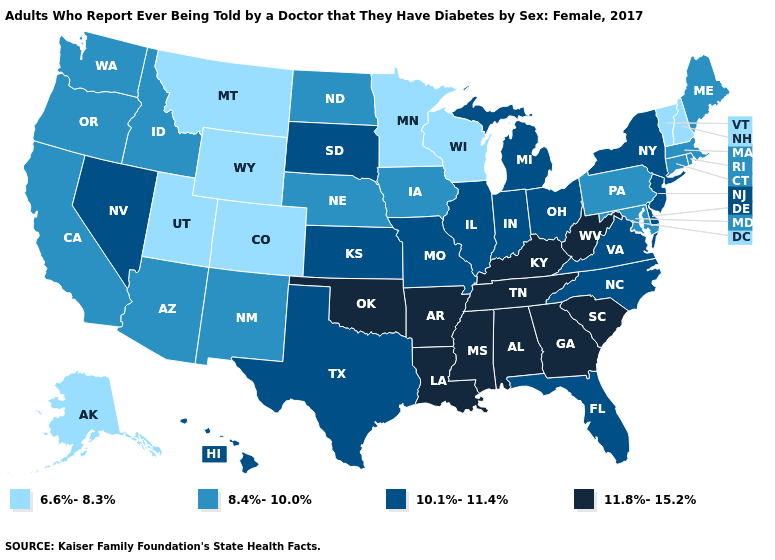What is the lowest value in the USA?
Be succinct. 6.6%-8.3%. Name the states that have a value in the range 8.4%-10.0%?
Be succinct. Arizona, California, Connecticut, Idaho, Iowa, Maine, Maryland, Massachusetts, Nebraska, New Mexico, North Dakota, Oregon, Pennsylvania, Rhode Island, Washington. Is the legend a continuous bar?
Write a very short answer. No. What is the value of Indiana?
Give a very brief answer. 10.1%-11.4%. Name the states that have a value in the range 11.8%-15.2%?
Answer briefly. Alabama, Arkansas, Georgia, Kentucky, Louisiana, Mississippi, Oklahoma, South Carolina, Tennessee, West Virginia. Does Massachusetts have a lower value than Delaware?
Give a very brief answer. Yes. What is the value of Ohio?
Write a very short answer. 10.1%-11.4%. Name the states that have a value in the range 10.1%-11.4%?
Answer briefly. Delaware, Florida, Hawaii, Illinois, Indiana, Kansas, Michigan, Missouri, Nevada, New Jersey, New York, North Carolina, Ohio, South Dakota, Texas, Virginia. Which states have the lowest value in the USA?
Be succinct. Alaska, Colorado, Minnesota, Montana, New Hampshire, Utah, Vermont, Wisconsin, Wyoming. What is the lowest value in the USA?
Quick response, please. 6.6%-8.3%. What is the value of Louisiana?
Be succinct. 11.8%-15.2%. Name the states that have a value in the range 8.4%-10.0%?
Keep it brief. Arizona, California, Connecticut, Idaho, Iowa, Maine, Maryland, Massachusetts, Nebraska, New Mexico, North Dakota, Oregon, Pennsylvania, Rhode Island, Washington. What is the lowest value in the MidWest?
Short answer required. 6.6%-8.3%. Does Illinois have the lowest value in the USA?
Keep it brief. No. What is the value of New Jersey?
Write a very short answer. 10.1%-11.4%. 